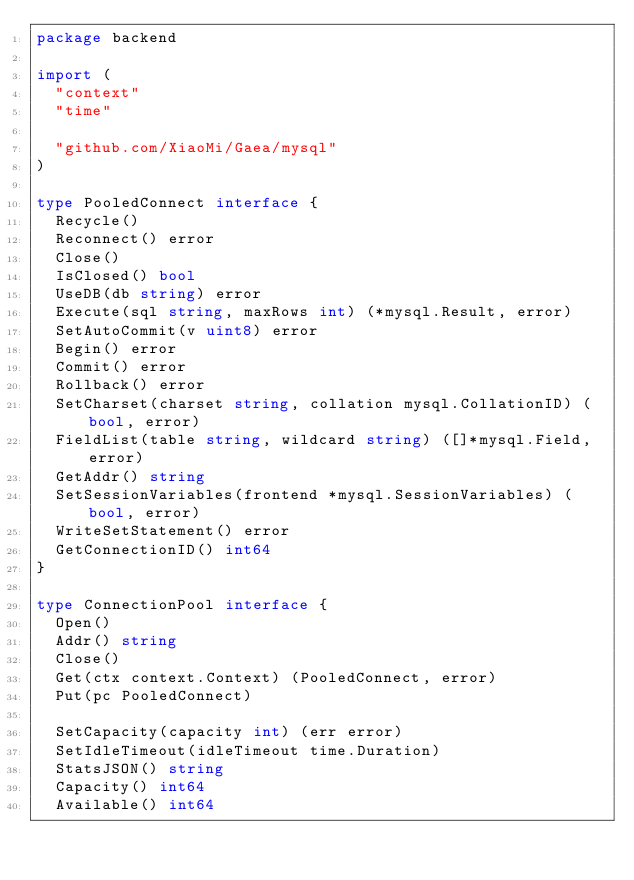Convert code to text. <code><loc_0><loc_0><loc_500><loc_500><_Go_>package backend

import (
	"context"
	"time"

	"github.com/XiaoMi/Gaea/mysql"
)

type PooledConnect interface {
	Recycle()
	Reconnect() error
	Close()
	IsClosed() bool
	UseDB(db string) error
	Execute(sql string, maxRows int) (*mysql.Result, error)
	SetAutoCommit(v uint8) error
	Begin() error
	Commit() error
	Rollback() error
	SetCharset(charset string, collation mysql.CollationID) (bool, error)
	FieldList(table string, wildcard string) ([]*mysql.Field, error)
	GetAddr() string
	SetSessionVariables(frontend *mysql.SessionVariables) (bool, error)
	WriteSetStatement() error
	GetConnectionID() int64
}

type ConnectionPool interface {
	Open()
	Addr() string
	Close()
	Get(ctx context.Context) (PooledConnect, error)
	Put(pc PooledConnect)

	SetCapacity(capacity int) (err error)
	SetIdleTimeout(idleTimeout time.Duration)
	StatsJSON() string
	Capacity() int64
	Available() int64</code> 